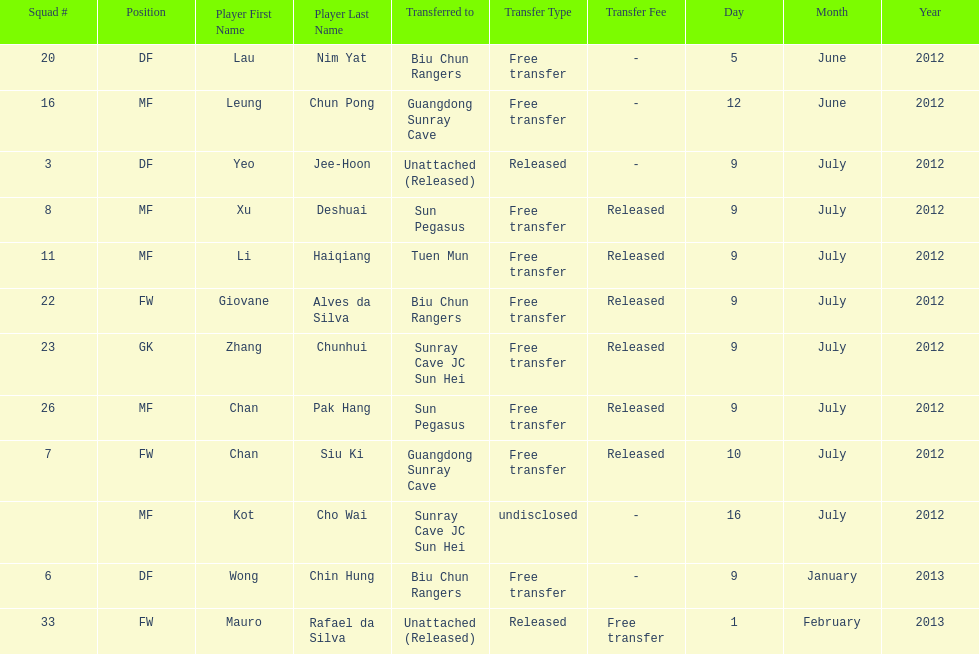What squad # is listed previous to squad # 7? 26. 